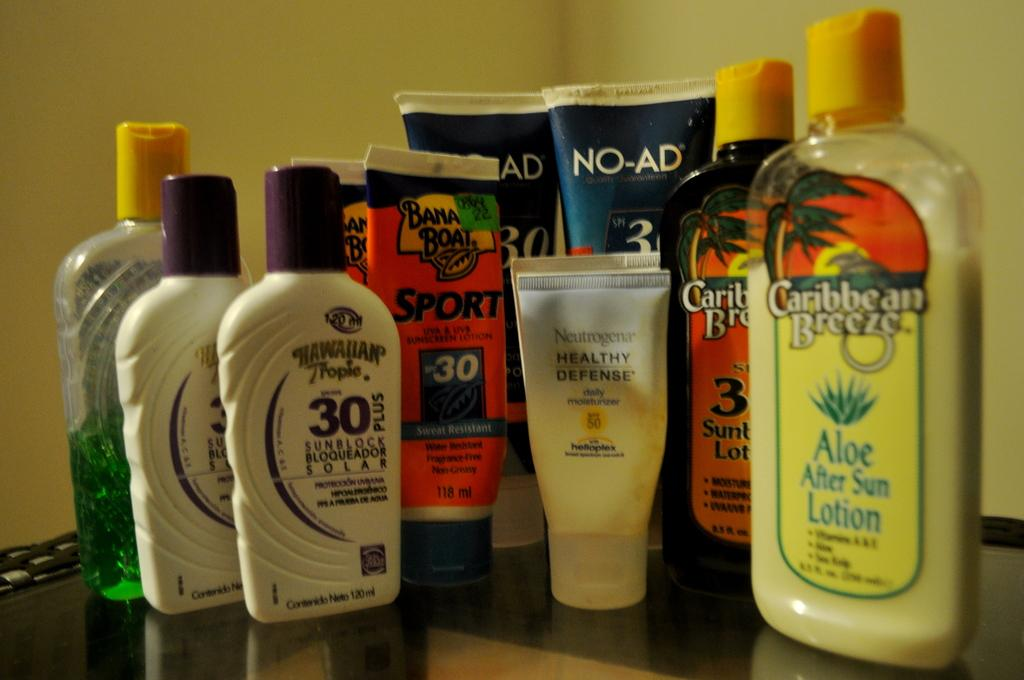Provide a one-sentence caption for the provided image. A group of suntan lotions from Banana Boat and Caribbean Breeze. 